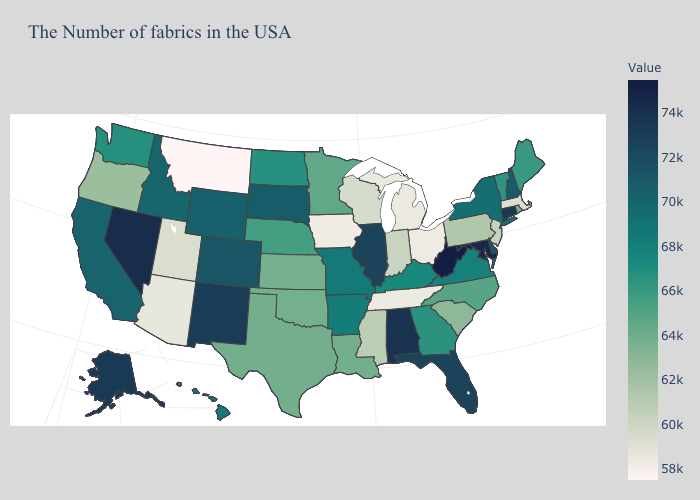Does Tennessee have the lowest value in the USA?
Be succinct. No. Does Indiana have the highest value in the MidWest?
Quick response, please. No. Is the legend a continuous bar?
Short answer required. Yes. Does Massachusetts have the lowest value in the Northeast?
Concise answer only. Yes. Among the states that border Minnesota , which have the highest value?
Be succinct. South Dakota. Among the states that border Delaware , does Pennsylvania have the lowest value?
Concise answer only. No. Does Montana have the lowest value in the USA?
Be succinct. Yes. 